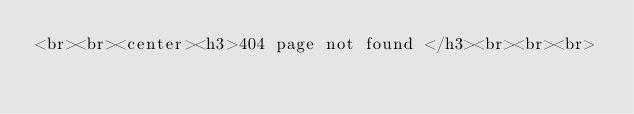Convert code to text. <code><loc_0><loc_0><loc_500><loc_500><_PHP_><br><br><center><h3>404 page not found </h3><br><br><br></code> 